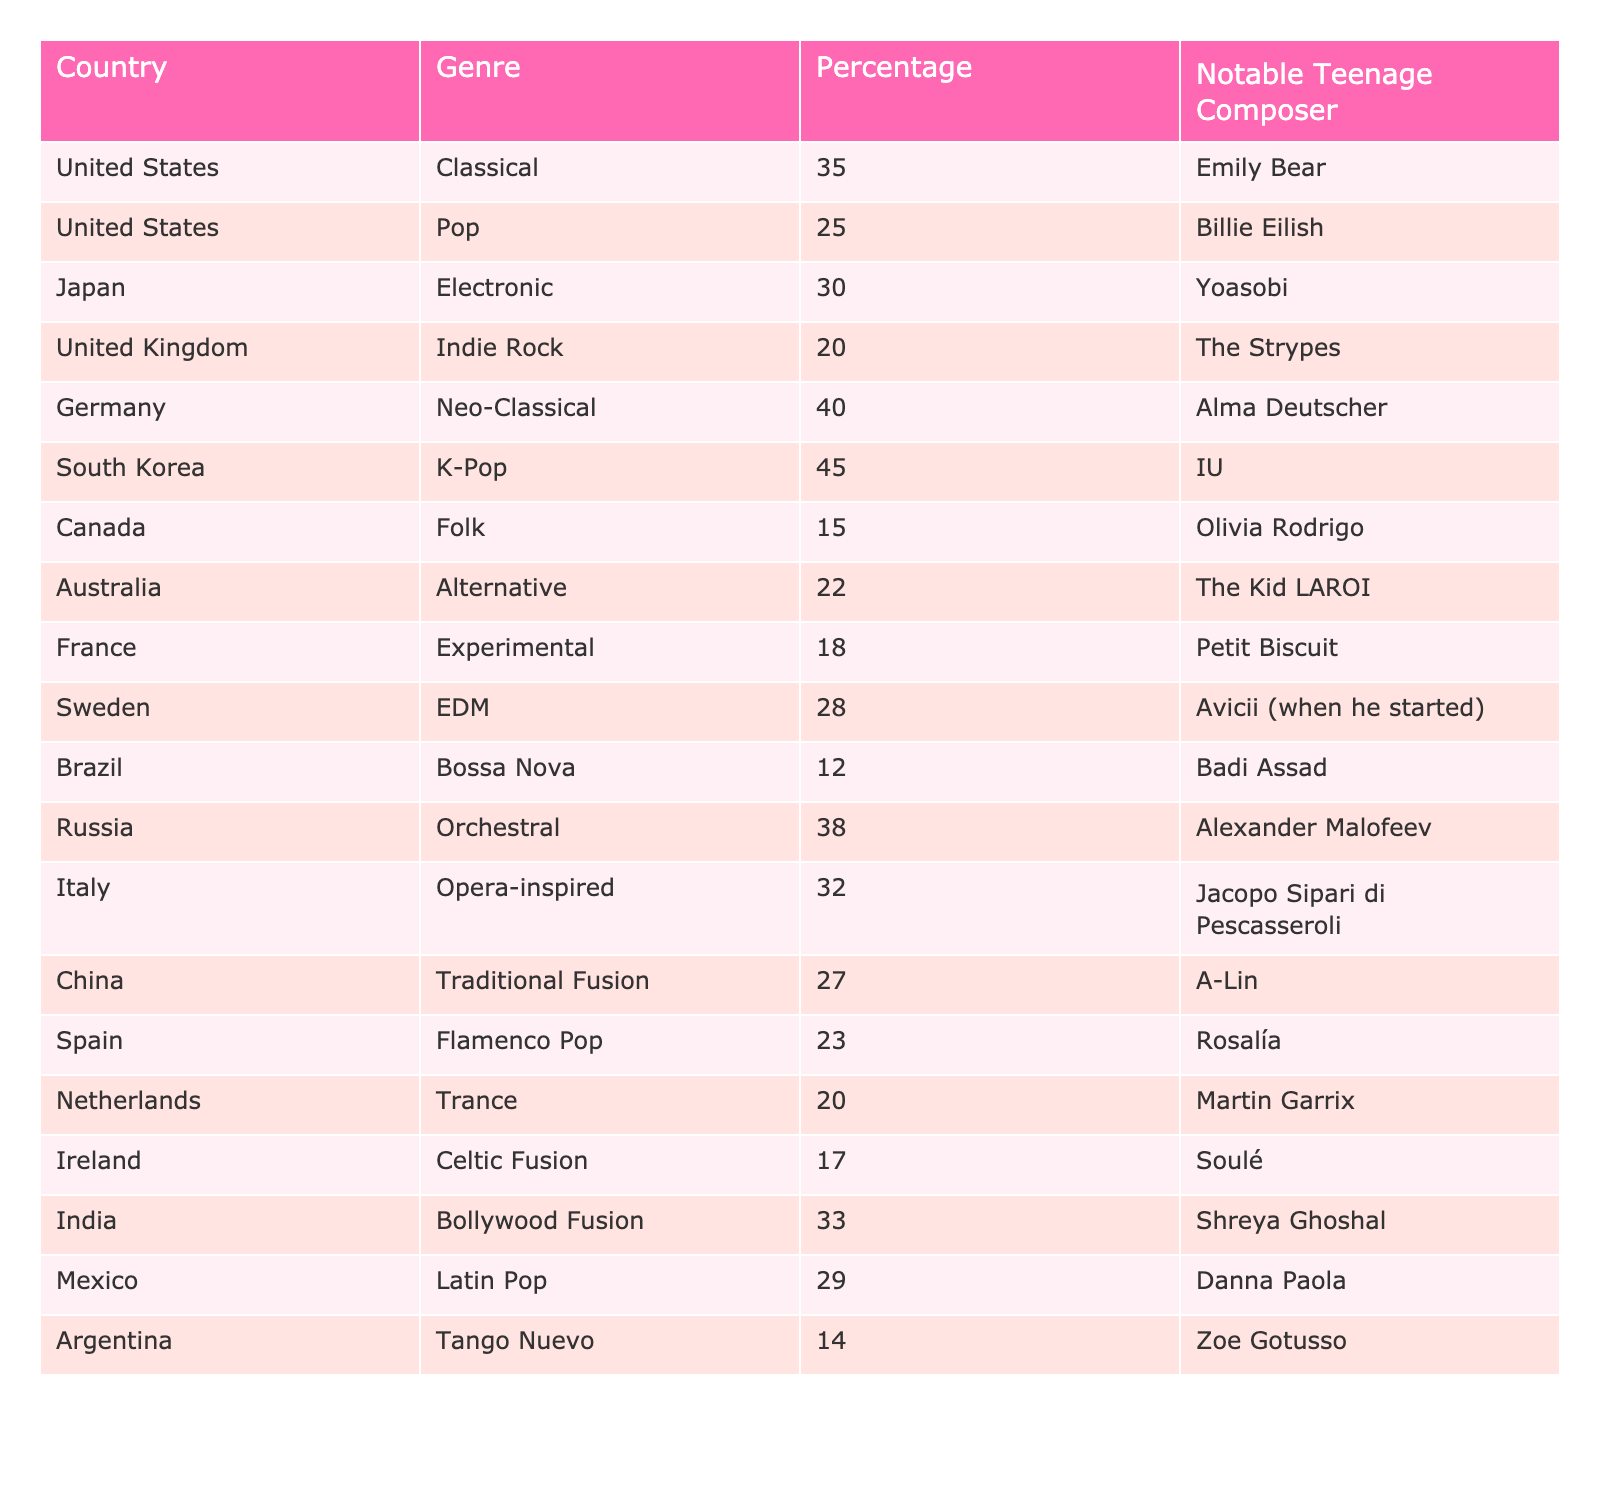What country has the highest percentage of teenage composers focused on K-Pop? The table shows that South Korea has the highest percentage at 45% specifically for K-Pop.
Answer: South Korea Which genre is the second most popular among teenage composers in the United States? In the United States, the most popular genre is Classical at 35%, and the second most popular genre is Pop at 25%.
Answer: Pop What is the percentage difference between orchestral and classical genres in Russia and the United States respectively? In Russia, the percentage for Orchestral is 38% and in the United States, Classical is 35%. The difference is 38 - 35 = 3%.
Answer: 3% Which country has a notable teenage composer associated with EDM? The table lists Sweden as having Avicii (when he started) as a notable teenage composer for the EDM genre.
Answer: Sweden Is there a genre that has a notable teenage composer in both Canada and the United States? According to the table, the genres in Canada and the US are Folk and Classical respectively and are unique to their countries, hence there is no overlap.
Answer: No What is the average percentage of teenage composers for the genres listed under the United Kingdom, Germany, and Italy? The percentages for these countries are: UK (20%), Germany (40%), and Italy (32%). Adding them gives 20 + 40 + 32 = 92, and dividing by 3 gives an average of 30.67%.
Answer: 30.67% Which genre is the least popular among teenage composers according to the table? Upon reviewing the table, Bossa Nova from Brazil has the lowest percentage at 12%.
Answer: Bossa Nova If you were to rank the countries by their percentage of teenage composers in Neo-Classical, which country would rank highest? Germany ranks highest for Neo-Classical with 40%, making it the only country listed under that genre in the table.
Answer: Germany How does the percentage of Classical composers in the United States compare to that in India? The United States has Classical at 35%, while India has Bollywood Fusion at 33%. The US percentage is therefore 2% higher.
Answer: 2% higher What genre is associated with the notable teenage composer, IU? The table notes that IU is associated with the K-Pop genre in South Korea.
Answer: K-Pop Which country has the highest percentage of teenage composers in Orchestral music? The table specifies that Russia has a 38% representation in Orchestral music, which is the highest among the countries listed.
Answer: Russia 